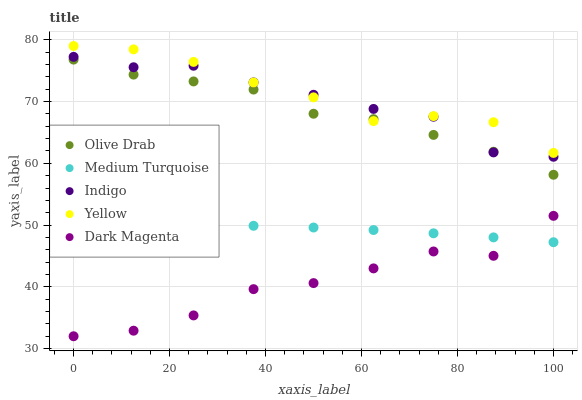Does Dark Magenta have the minimum area under the curve?
Answer yes or no. Yes. Does Yellow have the maximum area under the curve?
Answer yes or no. Yes. Does Indigo have the minimum area under the curve?
Answer yes or no. No. Does Indigo have the maximum area under the curve?
Answer yes or no. No. Is Medium Turquoise the smoothest?
Answer yes or no. Yes. Is Dark Magenta the roughest?
Answer yes or no. Yes. Is Indigo the smoothest?
Answer yes or no. No. Is Indigo the roughest?
Answer yes or no. No. Does Dark Magenta have the lowest value?
Answer yes or no. Yes. Does Indigo have the lowest value?
Answer yes or no. No. Does Yellow have the highest value?
Answer yes or no. Yes. Does Indigo have the highest value?
Answer yes or no. No. Is Medium Turquoise less than Indigo?
Answer yes or no. Yes. Is Olive Drab greater than Dark Magenta?
Answer yes or no. Yes. Does Olive Drab intersect Yellow?
Answer yes or no. Yes. Is Olive Drab less than Yellow?
Answer yes or no. No. Is Olive Drab greater than Yellow?
Answer yes or no. No. Does Medium Turquoise intersect Indigo?
Answer yes or no. No. 